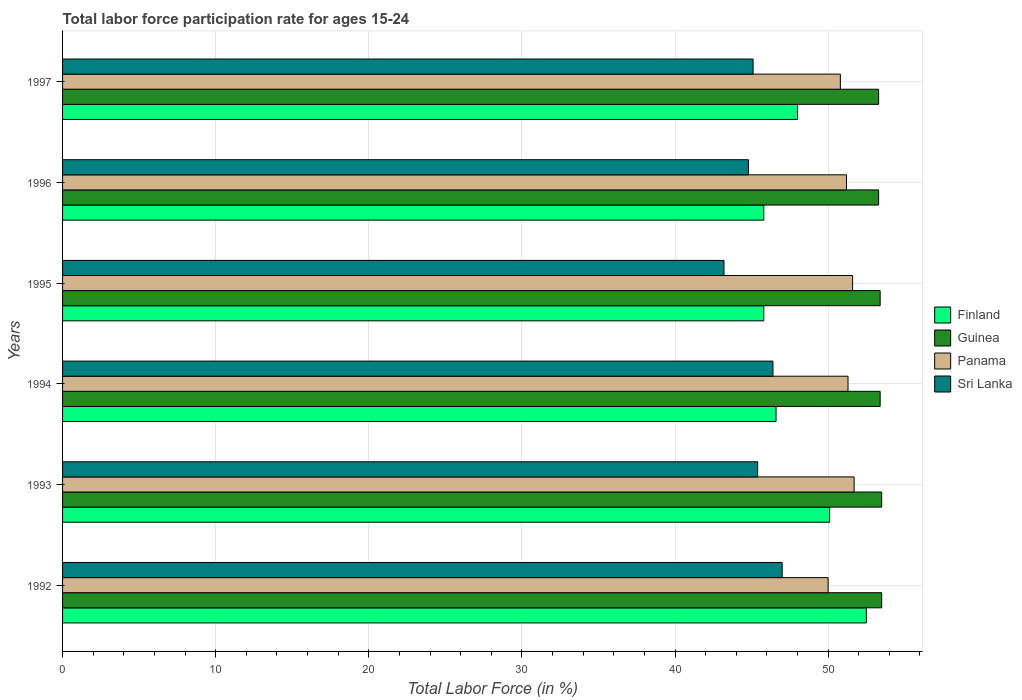How many different coloured bars are there?
Give a very brief answer. 4. How many groups of bars are there?
Provide a short and direct response. 6. Are the number of bars per tick equal to the number of legend labels?
Your response must be concise. Yes. How many bars are there on the 2nd tick from the top?
Provide a succinct answer. 4. What is the label of the 4th group of bars from the top?
Provide a succinct answer. 1994. In how many cases, is the number of bars for a given year not equal to the number of legend labels?
Provide a succinct answer. 0. What is the labor force participation rate in Panama in 1997?
Provide a succinct answer. 50.8. Across all years, what is the minimum labor force participation rate in Finland?
Make the answer very short. 45.8. In which year was the labor force participation rate in Panama maximum?
Keep it short and to the point. 1993. In which year was the labor force participation rate in Panama minimum?
Keep it short and to the point. 1992. What is the total labor force participation rate in Sri Lanka in the graph?
Offer a very short reply. 271.9. What is the difference between the labor force participation rate in Guinea in 1996 and that in 1997?
Offer a very short reply. 0. What is the difference between the labor force participation rate in Guinea in 1996 and the labor force participation rate in Finland in 1997?
Ensure brevity in your answer.  5.3. What is the average labor force participation rate in Guinea per year?
Keep it short and to the point. 53.4. In the year 1993, what is the difference between the labor force participation rate in Guinea and labor force participation rate in Panama?
Provide a succinct answer. 1.8. In how many years, is the labor force participation rate in Guinea greater than 46 %?
Provide a short and direct response. 6. What is the ratio of the labor force participation rate in Finland in 1996 to that in 1997?
Keep it short and to the point. 0.95. What is the difference between the highest and the second highest labor force participation rate in Sri Lanka?
Give a very brief answer. 0.6. What is the difference between the highest and the lowest labor force participation rate in Guinea?
Your answer should be very brief. 0.2. In how many years, is the labor force participation rate in Panama greater than the average labor force participation rate in Panama taken over all years?
Your response must be concise. 4. Is the sum of the labor force participation rate in Sri Lanka in 1992 and 1995 greater than the maximum labor force participation rate in Finland across all years?
Your response must be concise. Yes. Is it the case that in every year, the sum of the labor force participation rate in Guinea and labor force participation rate in Finland is greater than the sum of labor force participation rate in Sri Lanka and labor force participation rate in Panama?
Provide a succinct answer. No. What does the 4th bar from the bottom in 1995 represents?
Give a very brief answer. Sri Lanka. Is it the case that in every year, the sum of the labor force participation rate in Finland and labor force participation rate in Panama is greater than the labor force participation rate in Guinea?
Offer a terse response. Yes. How many bars are there?
Offer a very short reply. 24. Are all the bars in the graph horizontal?
Your answer should be very brief. Yes. Are the values on the major ticks of X-axis written in scientific E-notation?
Provide a short and direct response. No. Does the graph contain any zero values?
Provide a short and direct response. No. How many legend labels are there?
Keep it short and to the point. 4. How are the legend labels stacked?
Provide a succinct answer. Vertical. What is the title of the graph?
Offer a very short reply. Total labor force participation rate for ages 15-24. Does "Angola" appear as one of the legend labels in the graph?
Offer a very short reply. No. What is the Total Labor Force (in %) of Finland in 1992?
Your answer should be very brief. 52.5. What is the Total Labor Force (in %) in Guinea in 1992?
Make the answer very short. 53.5. What is the Total Labor Force (in %) in Finland in 1993?
Your answer should be compact. 50.1. What is the Total Labor Force (in %) of Guinea in 1993?
Provide a succinct answer. 53.5. What is the Total Labor Force (in %) in Panama in 1993?
Give a very brief answer. 51.7. What is the Total Labor Force (in %) of Sri Lanka in 1993?
Provide a succinct answer. 45.4. What is the Total Labor Force (in %) of Finland in 1994?
Make the answer very short. 46.6. What is the Total Labor Force (in %) in Guinea in 1994?
Make the answer very short. 53.4. What is the Total Labor Force (in %) of Panama in 1994?
Provide a short and direct response. 51.3. What is the Total Labor Force (in %) of Sri Lanka in 1994?
Provide a short and direct response. 46.4. What is the Total Labor Force (in %) in Finland in 1995?
Ensure brevity in your answer.  45.8. What is the Total Labor Force (in %) of Guinea in 1995?
Offer a terse response. 53.4. What is the Total Labor Force (in %) in Panama in 1995?
Your response must be concise. 51.6. What is the Total Labor Force (in %) in Sri Lanka in 1995?
Your response must be concise. 43.2. What is the Total Labor Force (in %) in Finland in 1996?
Give a very brief answer. 45.8. What is the Total Labor Force (in %) in Guinea in 1996?
Your answer should be compact. 53.3. What is the Total Labor Force (in %) of Panama in 1996?
Offer a terse response. 51.2. What is the Total Labor Force (in %) in Sri Lanka in 1996?
Keep it short and to the point. 44.8. What is the Total Labor Force (in %) in Finland in 1997?
Provide a succinct answer. 48. What is the Total Labor Force (in %) of Guinea in 1997?
Your response must be concise. 53.3. What is the Total Labor Force (in %) in Panama in 1997?
Give a very brief answer. 50.8. What is the Total Labor Force (in %) of Sri Lanka in 1997?
Your response must be concise. 45.1. Across all years, what is the maximum Total Labor Force (in %) in Finland?
Your answer should be very brief. 52.5. Across all years, what is the maximum Total Labor Force (in %) in Guinea?
Offer a very short reply. 53.5. Across all years, what is the maximum Total Labor Force (in %) of Panama?
Make the answer very short. 51.7. Across all years, what is the maximum Total Labor Force (in %) of Sri Lanka?
Your response must be concise. 47. Across all years, what is the minimum Total Labor Force (in %) in Finland?
Your answer should be very brief. 45.8. Across all years, what is the minimum Total Labor Force (in %) of Guinea?
Make the answer very short. 53.3. Across all years, what is the minimum Total Labor Force (in %) of Panama?
Offer a terse response. 50. Across all years, what is the minimum Total Labor Force (in %) of Sri Lanka?
Provide a succinct answer. 43.2. What is the total Total Labor Force (in %) in Finland in the graph?
Provide a succinct answer. 288.8. What is the total Total Labor Force (in %) of Guinea in the graph?
Make the answer very short. 320.4. What is the total Total Labor Force (in %) of Panama in the graph?
Keep it short and to the point. 306.6. What is the total Total Labor Force (in %) of Sri Lanka in the graph?
Make the answer very short. 271.9. What is the difference between the Total Labor Force (in %) of Finland in 1992 and that in 1993?
Ensure brevity in your answer.  2.4. What is the difference between the Total Labor Force (in %) in Panama in 1992 and that in 1993?
Ensure brevity in your answer.  -1.7. What is the difference between the Total Labor Force (in %) in Sri Lanka in 1992 and that in 1993?
Provide a succinct answer. 1.6. What is the difference between the Total Labor Force (in %) of Finland in 1992 and that in 1994?
Your answer should be compact. 5.9. What is the difference between the Total Labor Force (in %) of Panama in 1992 and that in 1994?
Your answer should be compact. -1.3. What is the difference between the Total Labor Force (in %) of Finland in 1992 and that in 1995?
Provide a succinct answer. 6.7. What is the difference between the Total Labor Force (in %) in Guinea in 1992 and that in 1995?
Your response must be concise. 0.1. What is the difference between the Total Labor Force (in %) in Panama in 1992 and that in 1995?
Offer a terse response. -1.6. What is the difference between the Total Labor Force (in %) of Sri Lanka in 1992 and that in 1996?
Ensure brevity in your answer.  2.2. What is the difference between the Total Labor Force (in %) in Finland in 1992 and that in 1997?
Offer a terse response. 4.5. What is the difference between the Total Labor Force (in %) of Panama in 1992 and that in 1997?
Make the answer very short. -0.8. What is the difference between the Total Labor Force (in %) in Sri Lanka in 1992 and that in 1997?
Make the answer very short. 1.9. What is the difference between the Total Labor Force (in %) in Finland in 1993 and that in 1994?
Provide a short and direct response. 3.5. What is the difference between the Total Labor Force (in %) of Finland in 1993 and that in 1995?
Ensure brevity in your answer.  4.3. What is the difference between the Total Labor Force (in %) of Guinea in 1993 and that in 1996?
Your answer should be very brief. 0.2. What is the difference between the Total Labor Force (in %) in Panama in 1993 and that in 1996?
Provide a short and direct response. 0.5. What is the difference between the Total Labor Force (in %) in Sri Lanka in 1993 and that in 1996?
Your answer should be compact. 0.6. What is the difference between the Total Labor Force (in %) of Finland in 1993 and that in 1997?
Keep it short and to the point. 2.1. What is the difference between the Total Labor Force (in %) in Finland in 1994 and that in 1995?
Make the answer very short. 0.8. What is the difference between the Total Labor Force (in %) of Guinea in 1994 and that in 1995?
Offer a very short reply. 0. What is the difference between the Total Labor Force (in %) in Panama in 1994 and that in 1995?
Provide a short and direct response. -0.3. What is the difference between the Total Labor Force (in %) in Panama in 1994 and that in 1996?
Ensure brevity in your answer.  0.1. What is the difference between the Total Labor Force (in %) in Sri Lanka in 1994 and that in 1996?
Your answer should be compact. 1.6. What is the difference between the Total Labor Force (in %) in Finland in 1994 and that in 1997?
Provide a short and direct response. -1.4. What is the difference between the Total Labor Force (in %) in Guinea in 1994 and that in 1997?
Provide a short and direct response. 0.1. What is the difference between the Total Labor Force (in %) in Sri Lanka in 1995 and that in 1996?
Give a very brief answer. -1.6. What is the difference between the Total Labor Force (in %) of Guinea in 1995 and that in 1997?
Make the answer very short. 0.1. What is the difference between the Total Labor Force (in %) of Guinea in 1996 and that in 1997?
Offer a terse response. 0. What is the difference between the Total Labor Force (in %) in Panama in 1996 and that in 1997?
Offer a very short reply. 0.4. What is the difference between the Total Labor Force (in %) of Finland in 1992 and the Total Labor Force (in %) of Guinea in 1993?
Keep it short and to the point. -1. What is the difference between the Total Labor Force (in %) of Guinea in 1992 and the Total Labor Force (in %) of Panama in 1993?
Your answer should be very brief. 1.8. What is the difference between the Total Labor Force (in %) in Panama in 1992 and the Total Labor Force (in %) in Sri Lanka in 1993?
Make the answer very short. 4.6. What is the difference between the Total Labor Force (in %) of Guinea in 1992 and the Total Labor Force (in %) of Sri Lanka in 1994?
Make the answer very short. 7.1. What is the difference between the Total Labor Force (in %) of Finland in 1992 and the Total Labor Force (in %) of Sri Lanka in 1995?
Provide a short and direct response. 9.3. What is the difference between the Total Labor Force (in %) in Guinea in 1992 and the Total Labor Force (in %) in Panama in 1995?
Give a very brief answer. 1.9. What is the difference between the Total Labor Force (in %) in Finland in 1992 and the Total Labor Force (in %) in Panama in 1996?
Keep it short and to the point. 1.3. What is the difference between the Total Labor Force (in %) in Finland in 1992 and the Total Labor Force (in %) in Sri Lanka in 1996?
Provide a short and direct response. 7.7. What is the difference between the Total Labor Force (in %) in Guinea in 1992 and the Total Labor Force (in %) in Panama in 1996?
Provide a succinct answer. 2.3. What is the difference between the Total Labor Force (in %) of Guinea in 1992 and the Total Labor Force (in %) of Sri Lanka in 1996?
Provide a succinct answer. 8.7. What is the difference between the Total Labor Force (in %) in Panama in 1992 and the Total Labor Force (in %) in Sri Lanka in 1996?
Your answer should be compact. 5.2. What is the difference between the Total Labor Force (in %) in Guinea in 1992 and the Total Labor Force (in %) in Sri Lanka in 1997?
Provide a short and direct response. 8.4. What is the difference between the Total Labor Force (in %) in Panama in 1992 and the Total Labor Force (in %) in Sri Lanka in 1997?
Provide a short and direct response. 4.9. What is the difference between the Total Labor Force (in %) in Finland in 1993 and the Total Labor Force (in %) in Sri Lanka in 1994?
Provide a succinct answer. 3.7. What is the difference between the Total Labor Force (in %) in Guinea in 1993 and the Total Labor Force (in %) in Sri Lanka in 1994?
Ensure brevity in your answer.  7.1. What is the difference between the Total Labor Force (in %) in Panama in 1993 and the Total Labor Force (in %) in Sri Lanka in 1994?
Offer a terse response. 5.3. What is the difference between the Total Labor Force (in %) in Finland in 1993 and the Total Labor Force (in %) in Guinea in 1995?
Your answer should be compact. -3.3. What is the difference between the Total Labor Force (in %) in Guinea in 1993 and the Total Labor Force (in %) in Panama in 1995?
Offer a terse response. 1.9. What is the difference between the Total Labor Force (in %) in Guinea in 1993 and the Total Labor Force (in %) in Sri Lanka in 1995?
Your answer should be compact. 10.3. What is the difference between the Total Labor Force (in %) of Finland in 1993 and the Total Labor Force (in %) of Panama in 1996?
Give a very brief answer. -1.1. What is the difference between the Total Labor Force (in %) of Guinea in 1993 and the Total Labor Force (in %) of Sri Lanka in 1996?
Offer a terse response. 8.7. What is the difference between the Total Labor Force (in %) of Finland in 1993 and the Total Labor Force (in %) of Guinea in 1997?
Offer a very short reply. -3.2. What is the difference between the Total Labor Force (in %) in Finland in 1993 and the Total Labor Force (in %) in Sri Lanka in 1997?
Your answer should be very brief. 5. What is the difference between the Total Labor Force (in %) in Guinea in 1993 and the Total Labor Force (in %) in Sri Lanka in 1997?
Offer a very short reply. 8.4. What is the difference between the Total Labor Force (in %) of Panama in 1993 and the Total Labor Force (in %) of Sri Lanka in 1997?
Your answer should be very brief. 6.6. What is the difference between the Total Labor Force (in %) of Finland in 1994 and the Total Labor Force (in %) of Panama in 1995?
Keep it short and to the point. -5. What is the difference between the Total Labor Force (in %) in Guinea in 1994 and the Total Labor Force (in %) in Sri Lanka in 1995?
Offer a very short reply. 10.2. What is the difference between the Total Labor Force (in %) in Panama in 1994 and the Total Labor Force (in %) in Sri Lanka in 1995?
Your answer should be compact. 8.1. What is the difference between the Total Labor Force (in %) in Guinea in 1994 and the Total Labor Force (in %) in Panama in 1996?
Your answer should be very brief. 2.2. What is the difference between the Total Labor Force (in %) in Panama in 1994 and the Total Labor Force (in %) in Sri Lanka in 1996?
Ensure brevity in your answer.  6.5. What is the difference between the Total Labor Force (in %) of Guinea in 1994 and the Total Labor Force (in %) of Sri Lanka in 1997?
Your response must be concise. 8.3. What is the difference between the Total Labor Force (in %) of Finland in 1995 and the Total Labor Force (in %) of Sri Lanka in 1996?
Provide a short and direct response. 1. What is the difference between the Total Labor Force (in %) of Guinea in 1995 and the Total Labor Force (in %) of Sri Lanka in 1996?
Provide a succinct answer. 8.6. What is the difference between the Total Labor Force (in %) of Panama in 1995 and the Total Labor Force (in %) of Sri Lanka in 1996?
Your response must be concise. 6.8. What is the difference between the Total Labor Force (in %) in Finland in 1995 and the Total Labor Force (in %) in Guinea in 1997?
Give a very brief answer. -7.5. What is the difference between the Total Labor Force (in %) in Finland in 1995 and the Total Labor Force (in %) in Panama in 1997?
Give a very brief answer. -5. What is the difference between the Total Labor Force (in %) in Guinea in 1995 and the Total Labor Force (in %) in Sri Lanka in 1997?
Your response must be concise. 8.3. What is the difference between the Total Labor Force (in %) of Panama in 1995 and the Total Labor Force (in %) of Sri Lanka in 1997?
Keep it short and to the point. 6.5. What is the difference between the Total Labor Force (in %) in Finland in 1996 and the Total Labor Force (in %) in Guinea in 1997?
Provide a succinct answer. -7.5. What is the difference between the Total Labor Force (in %) of Finland in 1996 and the Total Labor Force (in %) of Sri Lanka in 1997?
Offer a very short reply. 0.7. What is the difference between the Total Labor Force (in %) in Guinea in 1996 and the Total Labor Force (in %) in Sri Lanka in 1997?
Keep it short and to the point. 8.2. What is the average Total Labor Force (in %) in Finland per year?
Offer a very short reply. 48.13. What is the average Total Labor Force (in %) of Guinea per year?
Offer a very short reply. 53.4. What is the average Total Labor Force (in %) in Panama per year?
Ensure brevity in your answer.  51.1. What is the average Total Labor Force (in %) of Sri Lanka per year?
Provide a succinct answer. 45.32. In the year 1992, what is the difference between the Total Labor Force (in %) in Finland and Total Labor Force (in %) in Guinea?
Ensure brevity in your answer.  -1. In the year 1992, what is the difference between the Total Labor Force (in %) in Finland and Total Labor Force (in %) in Panama?
Provide a short and direct response. 2.5. In the year 1992, what is the difference between the Total Labor Force (in %) of Finland and Total Labor Force (in %) of Sri Lanka?
Provide a succinct answer. 5.5. In the year 1993, what is the difference between the Total Labor Force (in %) of Finland and Total Labor Force (in %) of Guinea?
Offer a very short reply. -3.4. In the year 1993, what is the difference between the Total Labor Force (in %) in Finland and Total Labor Force (in %) in Panama?
Your answer should be very brief. -1.6. In the year 1993, what is the difference between the Total Labor Force (in %) in Finland and Total Labor Force (in %) in Sri Lanka?
Offer a very short reply. 4.7. In the year 1993, what is the difference between the Total Labor Force (in %) in Panama and Total Labor Force (in %) in Sri Lanka?
Your answer should be compact. 6.3. In the year 1994, what is the difference between the Total Labor Force (in %) of Guinea and Total Labor Force (in %) of Sri Lanka?
Your answer should be compact. 7. In the year 1994, what is the difference between the Total Labor Force (in %) in Panama and Total Labor Force (in %) in Sri Lanka?
Your response must be concise. 4.9. In the year 1995, what is the difference between the Total Labor Force (in %) in Finland and Total Labor Force (in %) in Guinea?
Offer a very short reply. -7.6. In the year 1995, what is the difference between the Total Labor Force (in %) in Finland and Total Labor Force (in %) in Sri Lanka?
Offer a terse response. 2.6. In the year 1995, what is the difference between the Total Labor Force (in %) of Guinea and Total Labor Force (in %) of Panama?
Keep it short and to the point. 1.8. In the year 1995, what is the difference between the Total Labor Force (in %) in Guinea and Total Labor Force (in %) in Sri Lanka?
Give a very brief answer. 10.2. In the year 1995, what is the difference between the Total Labor Force (in %) in Panama and Total Labor Force (in %) in Sri Lanka?
Your answer should be compact. 8.4. In the year 1996, what is the difference between the Total Labor Force (in %) in Finland and Total Labor Force (in %) in Guinea?
Your response must be concise. -7.5. In the year 1996, what is the difference between the Total Labor Force (in %) of Finland and Total Labor Force (in %) of Panama?
Offer a very short reply. -5.4. In the year 1996, what is the difference between the Total Labor Force (in %) of Finland and Total Labor Force (in %) of Sri Lanka?
Provide a short and direct response. 1. In the year 1996, what is the difference between the Total Labor Force (in %) in Guinea and Total Labor Force (in %) in Panama?
Your response must be concise. 2.1. In the year 1996, what is the difference between the Total Labor Force (in %) in Guinea and Total Labor Force (in %) in Sri Lanka?
Make the answer very short. 8.5. In the year 1996, what is the difference between the Total Labor Force (in %) of Panama and Total Labor Force (in %) of Sri Lanka?
Make the answer very short. 6.4. In the year 1997, what is the difference between the Total Labor Force (in %) in Finland and Total Labor Force (in %) in Sri Lanka?
Provide a short and direct response. 2.9. In the year 1997, what is the difference between the Total Labor Force (in %) of Guinea and Total Labor Force (in %) of Panama?
Give a very brief answer. 2.5. In the year 1997, what is the difference between the Total Labor Force (in %) in Panama and Total Labor Force (in %) in Sri Lanka?
Ensure brevity in your answer.  5.7. What is the ratio of the Total Labor Force (in %) of Finland in 1992 to that in 1993?
Give a very brief answer. 1.05. What is the ratio of the Total Labor Force (in %) of Guinea in 1992 to that in 1993?
Provide a short and direct response. 1. What is the ratio of the Total Labor Force (in %) of Panama in 1992 to that in 1993?
Keep it short and to the point. 0.97. What is the ratio of the Total Labor Force (in %) in Sri Lanka in 1992 to that in 1993?
Provide a short and direct response. 1.04. What is the ratio of the Total Labor Force (in %) of Finland in 1992 to that in 1994?
Offer a very short reply. 1.13. What is the ratio of the Total Labor Force (in %) of Panama in 1992 to that in 1994?
Make the answer very short. 0.97. What is the ratio of the Total Labor Force (in %) in Sri Lanka in 1992 to that in 1994?
Offer a very short reply. 1.01. What is the ratio of the Total Labor Force (in %) in Finland in 1992 to that in 1995?
Your response must be concise. 1.15. What is the ratio of the Total Labor Force (in %) of Guinea in 1992 to that in 1995?
Your response must be concise. 1. What is the ratio of the Total Labor Force (in %) in Panama in 1992 to that in 1995?
Your answer should be very brief. 0.97. What is the ratio of the Total Labor Force (in %) of Sri Lanka in 1992 to that in 1995?
Provide a succinct answer. 1.09. What is the ratio of the Total Labor Force (in %) in Finland in 1992 to that in 1996?
Your response must be concise. 1.15. What is the ratio of the Total Labor Force (in %) of Panama in 1992 to that in 1996?
Offer a terse response. 0.98. What is the ratio of the Total Labor Force (in %) in Sri Lanka in 1992 to that in 1996?
Your answer should be very brief. 1.05. What is the ratio of the Total Labor Force (in %) in Finland in 1992 to that in 1997?
Give a very brief answer. 1.09. What is the ratio of the Total Labor Force (in %) in Guinea in 1992 to that in 1997?
Offer a very short reply. 1. What is the ratio of the Total Labor Force (in %) of Panama in 1992 to that in 1997?
Offer a terse response. 0.98. What is the ratio of the Total Labor Force (in %) of Sri Lanka in 1992 to that in 1997?
Give a very brief answer. 1.04. What is the ratio of the Total Labor Force (in %) in Finland in 1993 to that in 1994?
Ensure brevity in your answer.  1.08. What is the ratio of the Total Labor Force (in %) of Panama in 1993 to that in 1994?
Make the answer very short. 1.01. What is the ratio of the Total Labor Force (in %) in Sri Lanka in 1993 to that in 1994?
Make the answer very short. 0.98. What is the ratio of the Total Labor Force (in %) in Finland in 1993 to that in 1995?
Your response must be concise. 1.09. What is the ratio of the Total Labor Force (in %) of Sri Lanka in 1993 to that in 1995?
Your response must be concise. 1.05. What is the ratio of the Total Labor Force (in %) in Finland in 1993 to that in 1996?
Make the answer very short. 1.09. What is the ratio of the Total Labor Force (in %) in Panama in 1993 to that in 1996?
Offer a very short reply. 1.01. What is the ratio of the Total Labor Force (in %) in Sri Lanka in 1993 to that in 1996?
Give a very brief answer. 1.01. What is the ratio of the Total Labor Force (in %) of Finland in 1993 to that in 1997?
Offer a terse response. 1.04. What is the ratio of the Total Labor Force (in %) of Panama in 1993 to that in 1997?
Provide a short and direct response. 1.02. What is the ratio of the Total Labor Force (in %) in Finland in 1994 to that in 1995?
Your answer should be very brief. 1.02. What is the ratio of the Total Labor Force (in %) of Guinea in 1994 to that in 1995?
Ensure brevity in your answer.  1. What is the ratio of the Total Labor Force (in %) in Panama in 1994 to that in 1995?
Give a very brief answer. 0.99. What is the ratio of the Total Labor Force (in %) of Sri Lanka in 1994 to that in 1995?
Provide a succinct answer. 1.07. What is the ratio of the Total Labor Force (in %) in Finland in 1994 to that in 1996?
Keep it short and to the point. 1.02. What is the ratio of the Total Labor Force (in %) in Panama in 1994 to that in 1996?
Your answer should be compact. 1. What is the ratio of the Total Labor Force (in %) in Sri Lanka in 1994 to that in 1996?
Provide a succinct answer. 1.04. What is the ratio of the Total Labor Force (in %) in Finland in 1994 to that in 1997?
Your response must be concise. 0.97. What is the ratio of the Total Labor Force (in %) in Panama in 1994 to that in 1997?
Give a very brief answer. 1.01. What is the ratio of the Total Labor Force (in %) in Sri Lanka in 1994 to that in 1997?
Your answer should be compact. 1.03. What is the ratio of the Total Labor Force (in %) of Finland in 1995 to that in 1996?
Keep it short and to the point. 1. What is the ratio of the Total Labor Force (in %) of Guinea in 1995 to that in 1996?
Make the answer very short. 1. What is the ratio of the Total Labor Force (in %) of Panama in 1995 to that in 1996?
Offer a very short reply. 1.01. What is the ratio of the Total Labor Force (in %) of Finland in 1995 to that in 1997?
Provide a succinct answer. 0.95. What is the ratio of the Total Labor Force (in %) of Guinea in 1995 to that in 1997?
Your response must be concise. 1. What is the ratio of the Total Labor Force (in %) of Panama in 1995 to that in 1997?
Make the answer very short. 1.02. What is the ratio of the Total Labor Force (in %) in Sri Lanka in 1995 to that in 1997?
Your answer should be very brief. 0.96. What is the ratio of the Total Labor Force (in %) of Finland in 1996 to that in 1997?
Your answer should be very brief. 0.95. What is the ratio of the Total Labor Force (in %) of Panama in 1996 to that in 1997?
Provide a succinct answer. 1.01. What is the ratio of the Total Labor Force (in %) of Sri Lanka in 1996 to that in 1997?
Make the answer very short. 0.99. What is the difference between the highest and the second highest Total Labor Force (in %) of Guinea?
Make the answer very short. 0. What is the difference between the highest and the second highest Total Labor Force (in %) in Panama?
Offer a very short reply. 0.1. What is the difference between the highest and the second highest Total Labor Force (in %) of Sri Lanka?
Give a very brief answer. 0.6. What is the difference between the highest and the lowest Total Labor Force (in %) in Finland?
Ensure brevity in your answer.  6.7. What is the difference between the highest and the lowest Total Labor Force (in %) in Guinea?
Your response must be concise. 0.2. What is the difference between the highest and the lowest Total Labor Force (in %) in Panama?
Provide a short and direct response. 1.7. 